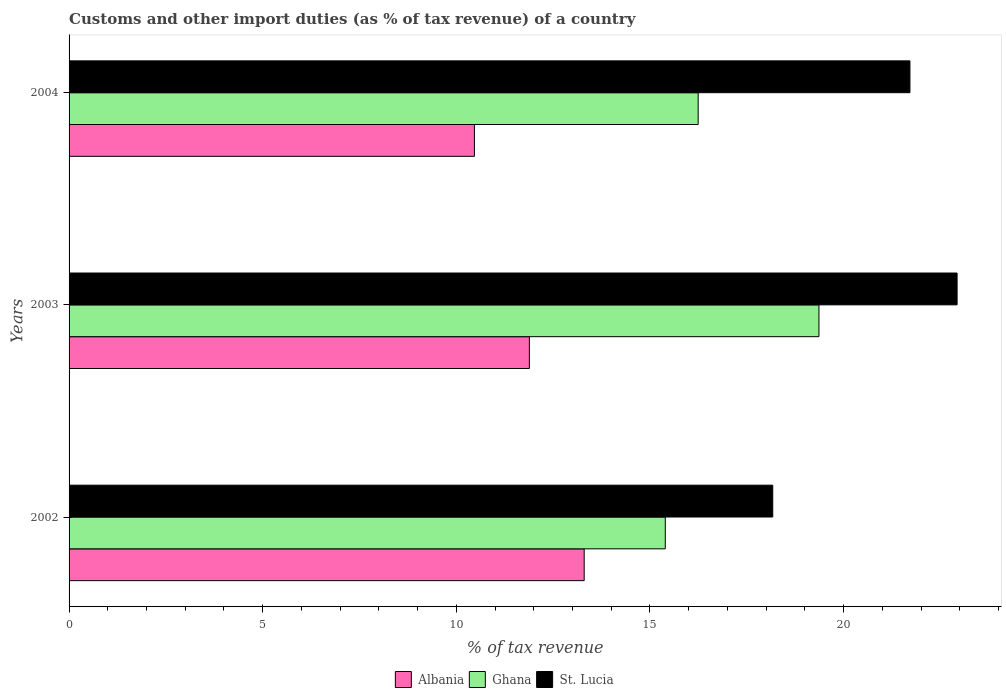How many different coloured bars are there?
Offer a terse response. 3. How many groups of bars are there?
Provide a short and direct response. 3. Are the number of bars on each tick of the Y-axis equal?
Provide a succinct answer. Yes. How many bars are there on the 1st tick from the top?
Provide a short and direct response. 3. In how many cases, is the number of bars for a given year not equal to the number of legend labels?
Your answer should be very brief. 0. What is the percentage of tax revenue from customs in St. Lucia in 2003?
Ensure brevity in your answer.  22.93. Across all years, what is the maximum percentage of tax revenue from customs in St. Lucia?
Keep it short and to the point. 22.93. Across all years, what is the minimum percentage of tax revenue from customs in Albania?
Offer a terse response. 10.47. In which year was the percentage of tax revenue from customs in Ghana maximum?
Your response must be concise. 2003. In which year was the percentage of tax revenue from customs in Ghana minimum?
Provide a succinct answer. 2002. What is the total percentage of tax revenue from customs in Ghana in the graph?
Offer a terse response. 51.01. What is the difference between the percentage of tax revenue from customs in Ghana in 2002 and that in 2003?
Make the answer very short. -3.97. What is the difference between the percentage of tax revenue from customs in Ghana in 2003 and the percentage of tax revenue from customs in St. Lucia in 2002?
Give a very brief answer. 1.19. What is the average percentage of tax revenue from customs in Ghana per year?
Keep it short and to the point. 17. In the year 2004, what is the difference between the percentage of tax revenue from customs in St. Lucia and percentage of tax revenue from customs in Albania?
Keep it short and to the point. 11.25. In how many years, is the percentage of tax revenue from customs in Ghana greater than 19 %?
Give a very brief answer. 1. What is the ratio of the percentage of tax revenue from customs in Albania in 2002 to that in 2004?
Provide a succinct answer. 1.27. Is the difference between the percentage of tax revenue from customs in St. Lucia in 2002 and 2003 greater than the difference between the percentage of tax revenue from customs in Albania in 2002 and 2003?
Provide a succinct answer. No. What is the difference between the highest and the second highest percentage of tax revenue from customs in Albania?
Your answer should be very brief. 1.42. What is the difference between the highest and the lowest percentage of tax revenue from customs in Albania?
Your answer should be compact. 2.83. What does the 2nd bar from the top in 2004 represents?
Your answer should be compact. Ghana. What does the 1st bar from the bottom in 2003 represents?
Offer a very short reply. Albania. Are all the bars in the graph horizontal?
Provide a short and direct response. Yes. Does the graph contain any zero values?
Provide a succinct answer. No. Where does the legend appear in the graph?
Give a very brief answer. Bottom center. How many legend labels are there?
Provide a succinct answer. 3. What is the title of the graph?
Offer a terse response. Customs and other import duties (as % of tax revenue) of a country. Does "Rwanda" appear as one of the legend labels in the graph?
Your answer should be very brief. No. What is the label or title of the X-axis?
Offer a very short reply. % of tax revenue. What is the label or title of the Y-axis?
Offer a terse response. Years. What is the % of tax revenue of Albania in 2002?
Ensure brevity in your answer.  13.3. What is the % of tax revenue of Ghana in 2002?
Provide a short and direct response. 15.4. What is the % of tax revenue of St. Lucia in 2002?
Your answer should be compact. 18.17. What is the % of tax revenue in Albania in 2003?
Ensure brevity in your answer.  11.89. What is the % of tax revenue of Ghana in 2003?
Keep it short and to the point. 19.36. What is the % of tax revenue in St. Lucia in 2003?
Offer a very short reply. 22.93. What is the % of tax revenue in Albania in 2004?
Keep it short and to the point. 10.47. What is the % of tax revenue of Ghana in 2004?
Provide a succinct answer. 16.25. What is the % of tax revenue of St. Lucia in 2004?
Your answer should be compact. 21.71. Across all years, what is the maximum % of tax revenue of Albania?
Provide a short and direct response. 13.3. Across all years, what is the maximum % of tax revenue in Ghana?
Ensure brevity in your answer.  19.36. Across all years, what is the maximum % of tax revenue of St. Lucia?
Your answer should be very brief. 22.93. Across all years, what is the minimum % of tax revenue of Albania?
Your answer should be very brief. 10.47. Across all years, what is the minimum % of tax revenue in Ghana?
Keep it short and to the point. 15.4. Across all years, what is the minimum % of tax revenue in St. Lucia?
Offer a terse response. 18.17. What is the total % of tax revenue of Albania in the graph?
Provide a short and direct response. 35.66. What is the total % of tax revenue in Ghana in the graph?
Offer a terse response. 51.01. What is the total % of tax revenue in St. Lucia in the graph?
Ensure brevity in your answer.  62.82. What is the difference between the % of tax revenue in Albania in 2002 and that in 2003?
Keep it short and to the point. 1.42. What is the difference between the % of tax revenue of Ghana in 2002 and that in 2003?
Keep it short and to the point. -3.97. What is the difference between the % of tax revenue of St. Lucia in 2002 and that in 2003?
Your response must be concise. -4.76. What is the difference between the % of tax revenue in Albania in 2002 and that in 2004?
Provide a short and direct response. 2.83. What is the difference between the % of tax revenue in Ghana in 2002 and that in 2004?
Provide a short and direct response. -0.85. What is the difference between the % of tax revenue in St. Lucia in 2002 and that in 2004?
Give a very brief answer. -3.54. What is the difference between the % of tax revenue of Albania in 2003 and that in 2004?
Provide a short and direct response. 1.42. What is the difference between the % of tax revenue in Ghana in 2003 and that in 2004?
Keep it short and to the point. 3.12. What is the difference between the % of tax revenue in St. Lucia in 2003 and that in 2004?
Provide a short and direct response. 1.22. What is the difference between the % of tax revenue of Albania in 2002 and the % of tax revenue of Ghana in 2003?
Give a very brief answer. -6.06. What is the difference between the % of tax revenue in Albania in 2002 and the % of tax revenue in St. Lucia in 2003?
Offer a terse response. -9.63. What is the difference between the % of tax revenue of Ghana in 2002 and the % of tax revenue of St. Lucia in 2003?
Make the answer very short. -7.54. What is the difference between the % of tax revenue of Albania in 2002 and the % of tax revenue of Ghana in 2004?
Offer a very short reply. -2.94. What is the difference between the % of tax revenue in Albania in 2002 and the % of tax revenue in St. Lucia in 2004?
Offer a very short reply. -8.41. What is the difference between the % of tax revenue of Ghana in 2002 and the % of tax revenue of St. Lucia in 2004?
Ensure brevity in your answer.  -6.32. What is the difference between the % of tax revenue of Albania in 2003 and the % of tax revenue of Ghana in 2004?
Your answer should be compact. -4.36. What is the difference between the % of tax revenue of Albania in 2003 and the % of tax revenue of St. Lucia in 2004?
Give a very brief answer. -9.83. What is the difference between the % of tax revenue of Ghana in 2003 and the % of tax revenue of St. Lucia in 2004?
Your answer should be very brief. -2.35. What is the average % of tax revenue of Albania per year?
Offer a terse response. 11.89. What is the average % of tax revenue of Ghana per year?
Make the answer very short. 17. What is the average % of tax revenue of St. Lucia per year?
Offer a very short reply. 20.94. In the year 2002, what is the difference between the % of tax revenue in Albania and % of tax revenue in Ghana?
Your response must be concise. -2.09. In the year 2002, what is the difference between the % of tax revenue in Albania and % of tax revenue in St. Lucia?
Make the answer very short. -4.87. In the year 2002, what is the difference between the % of tax revenue in Ghana and % of tax revenue in St. Lucia?
Your response must be concise. -2.78. In the year 2003, what is the difference between the % of tax revenue of Albania and % of tax revenue of Ghana?
Your answer should be compact. -7.48. In the year 2003, what is the difference between the % of tax revenue of Albania and % of tax revenue of St. Lucia?
Offer a terse response. -11.04. In the year 2003, what is the difference between the % of tax revenue of Ghana and % of tax revenue of St. Lucia?
Make the answer very short. -3.57. In the year 2004, what is the difference between the % of tax revenue in Albania and % of tax revenue in Ghana?
Your answer should be compact. -5.78. In the year 2004, what is the difference between the % of tax revenue of Albania and % of tax revenue of St. Lucia?
Provide a succinct answer. -11.25. In the year 2004, what is the difference between the % of tax revenue of Ghana and % of tax revenue of St. Lucia?
Keep it short and to the point. -5.47. What is the ratio of the % of tax revenue of Albania in 2002 to that in 2003?
Offer a very short reply. 1.12. What is the ratio of the % of tax revenue in Ghana in 2002 to that in 2003?
Keep it short and to the point. 0.8. What is the ratio of the % of tax revenue in St. Lucia in 2002 to that in 2003?
Offer a very short reply. 0.79. What is the ratio of the % of tax revenue of Albania in 2002 to that in 2004?
Make the answer very short. 1.27. What is the ratio of the % of tax revenue of Ghana in 2002 to that in 2004?
Provide a succinct answer. 0.95. What is the ratio of the % of tax revenue in St. Lucia in 2002 to that in 2004?
Keep it short and to the point. 0.84. What is the ratio of the % of tax revenue in Albania in 2003 to that in 2004?
Make the answer very short. 1.14. What is the ratio of the % of tax revenue in Ghana in 2003 to that in 2004?
Your answer should be compact. 1.19. What is the ratio of the % of tax revenue in St. Lucia in 2003 to that in 2004?
Make the answer very short. 1.06. What is the difference between the highest and the second highest % of tax revenue of Albania?
Your answer should be very brief. 1.42. What is the difference between the highest and the second highest % of tax revenue of Ghana?
Provide a succinct answer. 3.12. What is the difference between the highest and the second highest % of tax revenue of St. Lucia?
Your answer should be compact. 1.22. What is the difference between the highest and the lowest % of tax revenue of Albania?
Your response must be concise. 2.83. What is the difference between the highest and the lowest % of tax revenue in Ghana?
Offer a very short reply. 3.97. What is the difference between the highest and the lowest % of tax revenue in St. Lucia?
Offer a terse response. 4.76. 